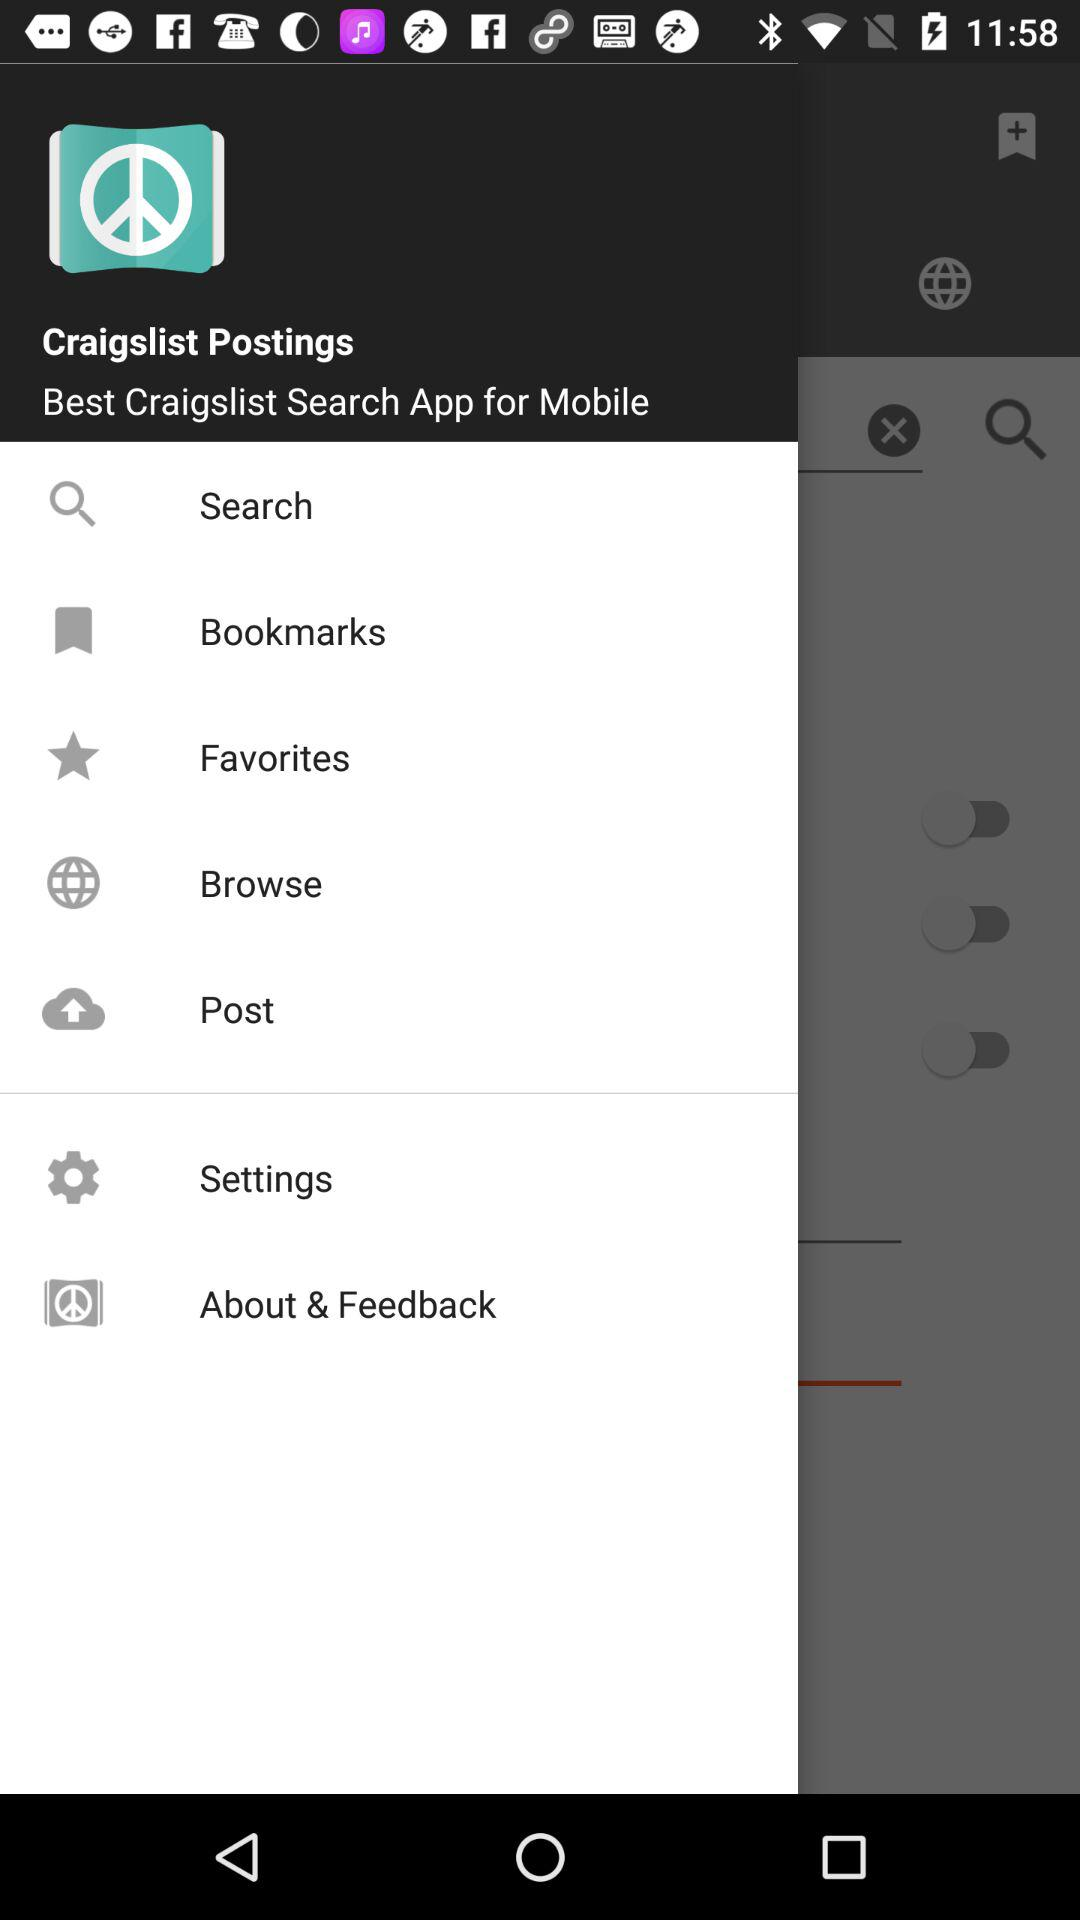What is the name of the application? The name of the application is "Craigslist Postings". 